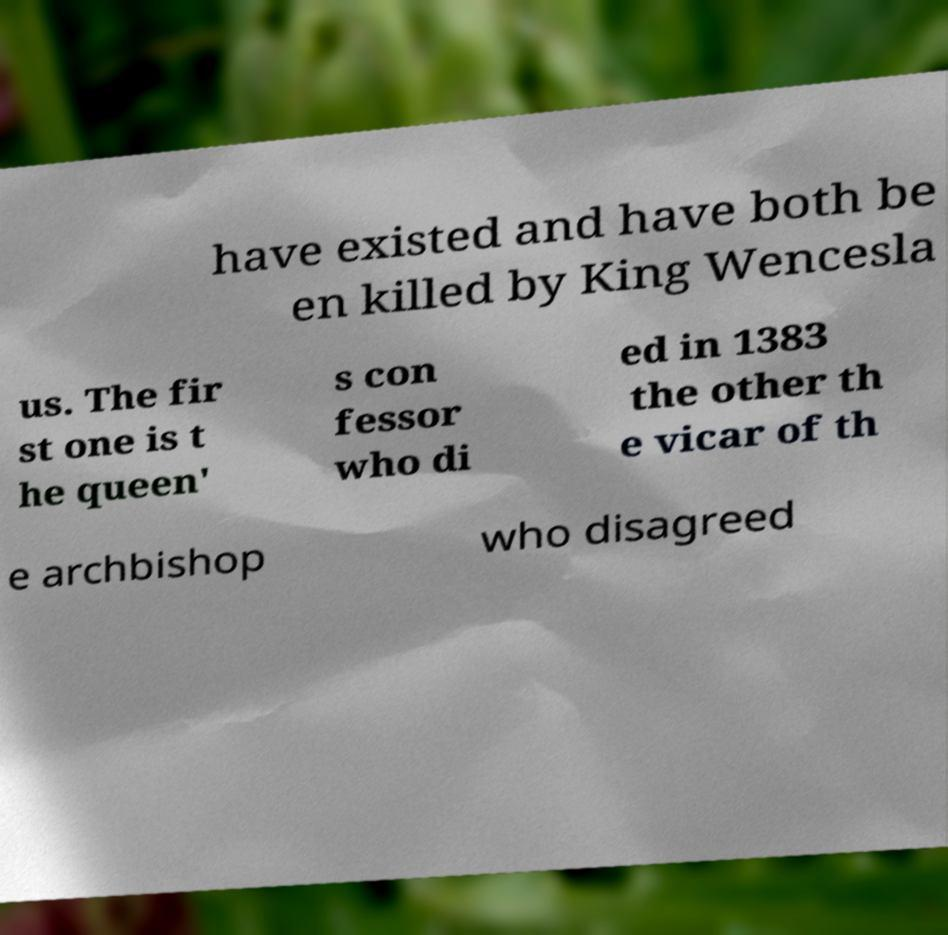Could you assist in decoding the text presented in this image and type it out clearly? have existed and have both be en killed by King Wencesla us. The fir st one is t he queen' s con fessor who di ed in 1383 the other th e vicar of th e archbishop who disagreed 